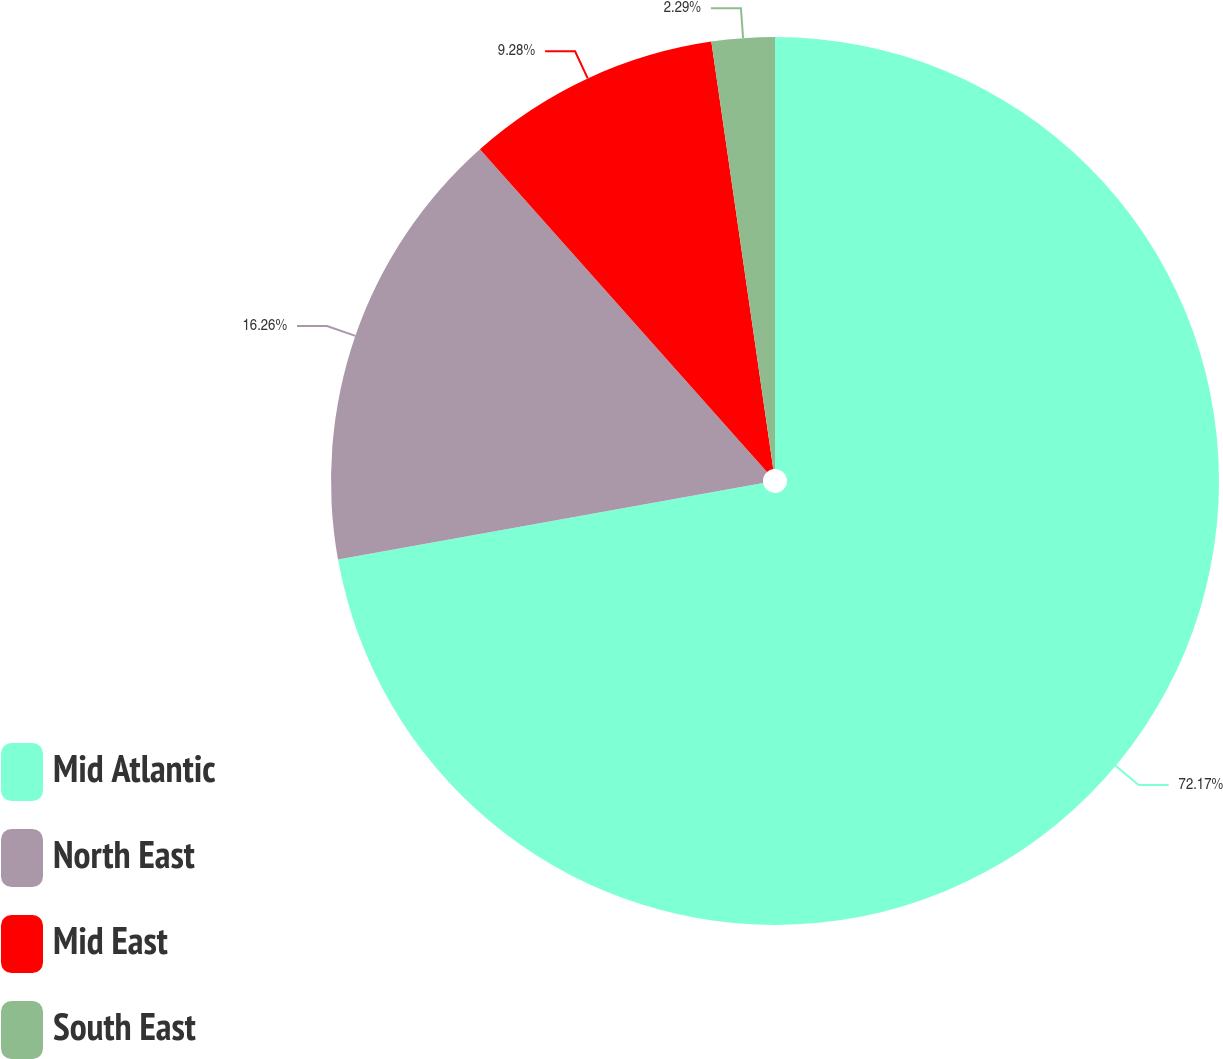Convert chart to OTSL. <chart><loc_0><loc_0><loc_500><loc_500><pie_chart><fcel>Mid Atlantic<fcel>North East<fcel>Mid East<fcel>South East<nl><fcel>72.17%<fcel>16.26%<fcel>9.28%<fcel>2.29%<nl></chart> 